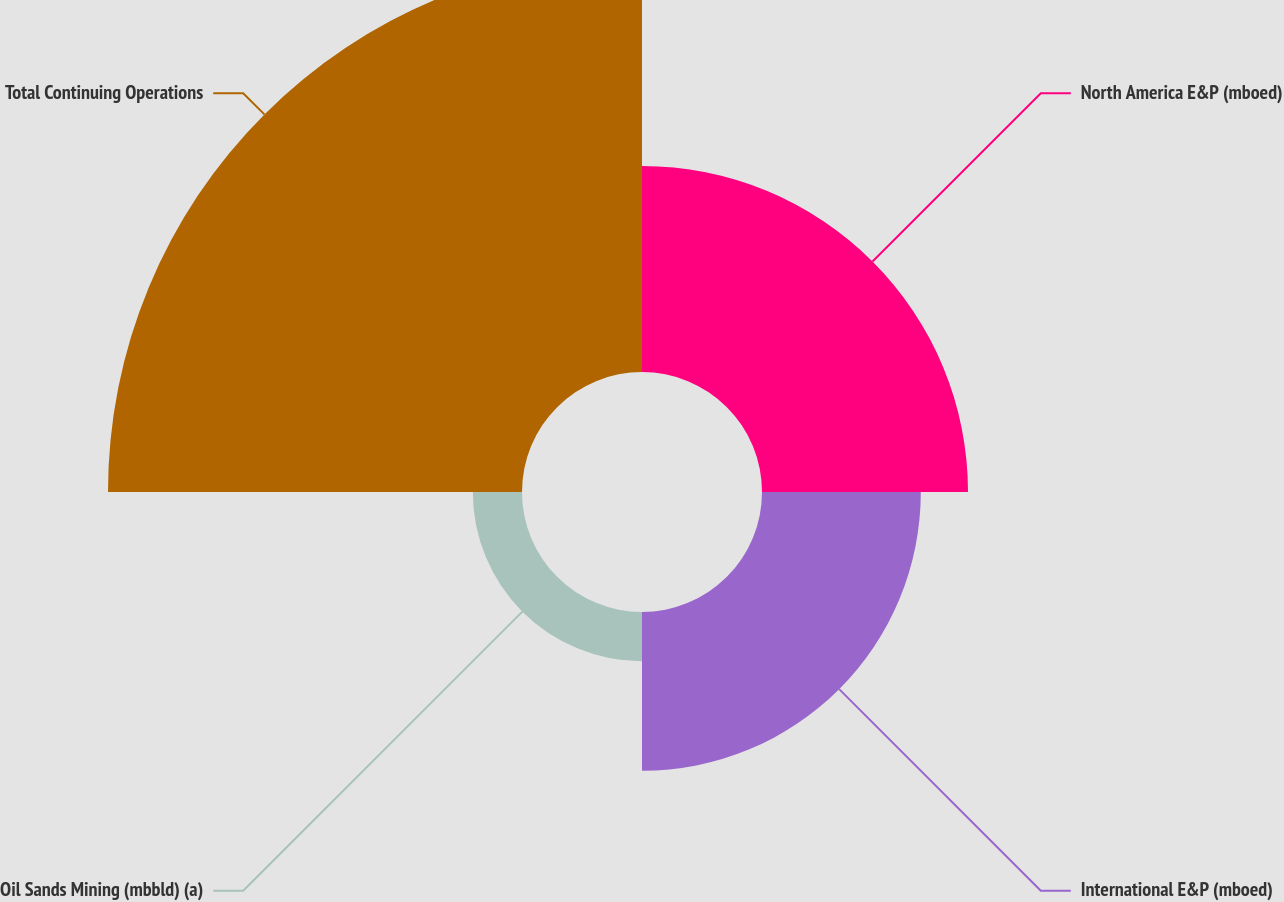Convert chart to OTSL. <chart><loc_0><loc_0><loc_500><loc_500><pie_chart><fcel>North America E&P (mboed)<fcel>International E&P (mboed)<fcel>Oil Sands Mining (mbbld) (a)<fcel>Total Continuing Operations<nl><fcel>24.88%<fcel>19.18%<fcel>5.94%<fcel>50.0%<nl></chart> 